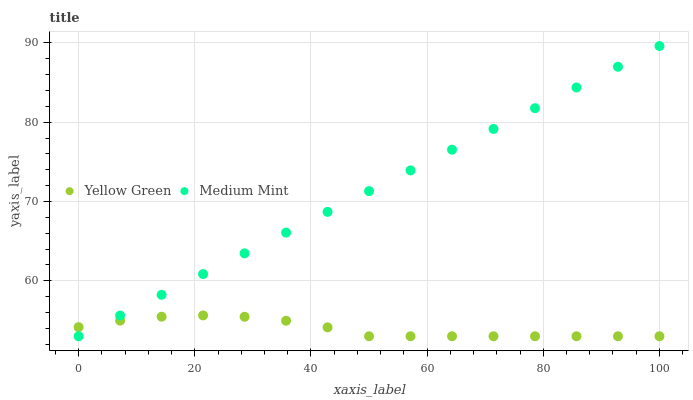Does Yellow Green have the minimum area under the curve?
Answer yes or no. Yes. Does Medium Mint have the maximum area under the curve?
Answer yes or no. Yes. Does Yellow Green have the maximum area under the curve?
Answer yes or no. No. Is Medium Mint the smoothest?
Answer yes or no. Yes. Is Yellow Green the roughest?
Answer yes or no. Yes. Is Yellow Green the smoothest?
Answer yes or no. No. Does Medium Mint have the lowest value?
Answer yes or no. Yes. Does Medium Mint have the highest value?
Answer yes or no. Yes. Does Yellow Green have the highest value?
Answer yes or no. No. Does Yellow Green intersect Medium Mint?
Answer yes or no. Yes. Is Yellow Green less than Medium Mint?
Answer yes or no. No. Is Yellow Green greater than Medium Mint?
Answer yes or no. No. 